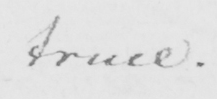Transcribe the text shown in this historical manuscript line. truce . 